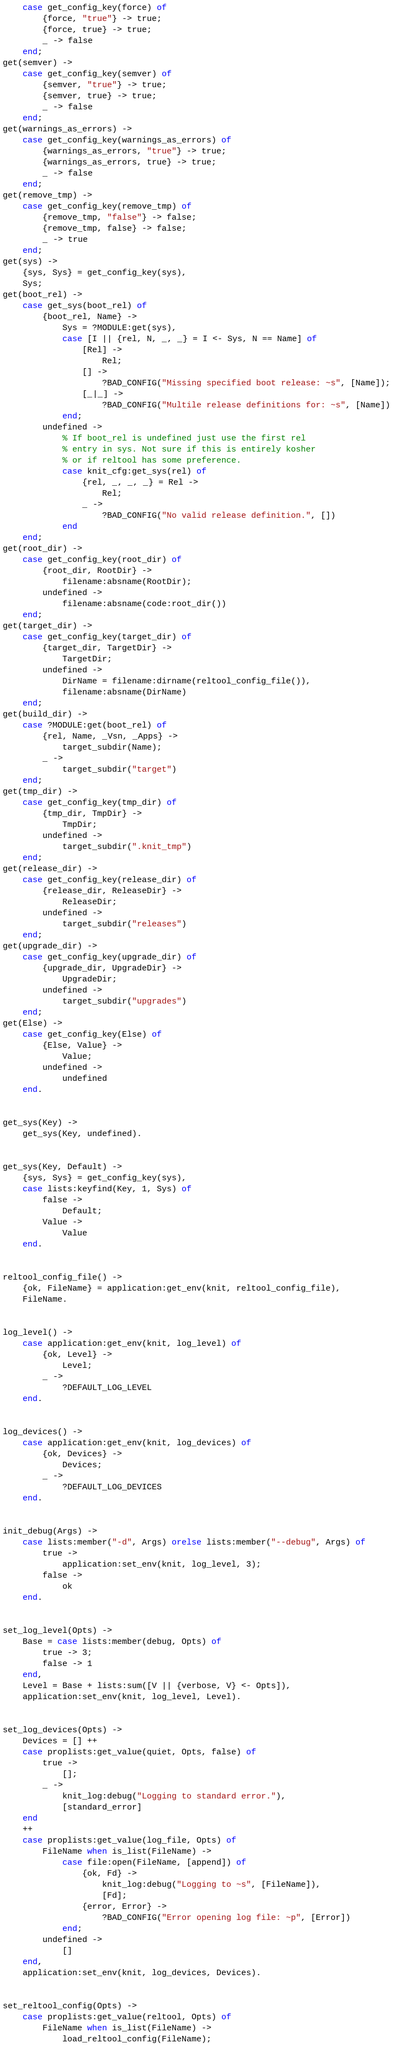<code> <loc_0><loc_0><loc_500><loc_500><_Erlang_>    case get_config_key(force) of
        {force, "true"} -> true;
        {force, true} -> true;
        _ -> false
    end;
get(semver) ->
    case get_config_key(semver) of
        {semver, "true"} -> true;
        {semver, true} -> true;
        _ -> false
    end;
get(warnings_as_errors) ->
    case get_config_key(warnings_as_errors) of
        {warnings_as_errors, "true"} -> true;
        {warnings_as_errors, true} -> true;
        _ -> false
    end;
get(remove_tmp) ->
    case get_config_key(remove_tmp) of
        {remove_tmp, "false"} -> false;
        {remove_tmp, false} -> false;
        _ -> true
    end;
get(sys) ->
    {sys, Sys} = get_config_key(sys),
    Sys;
get(boot_rel) ->
    case get_sys(boot_rel) of
        {boot_rel, Name} ->
            Sys = ?MODULE:get(sys),
            case [I || {rel, N, _, _} = I <- Sys, N == Name] of
                [Rel] ->
                    Rel;
                [] ->
                    ?BAD_CONFIG("Missing specified boot release: ~s", [Name]);
                [_|_] ->
                    ?BAD_CONFIG("Multile release definitions for: ~s", [Name])
            end;
        undefined ->
            % If boot_rel is undefined just use the first rel
            % entry in sys. Not sure if this is entirely kosher
            % or if reltool has some preference.
            case knit_cfg:get_sys(rel) of
                {rel, _, _, _} = Rel ->
                    Rel;
                _ ->
                    ?BAD_CONFIG("No valid release definition.", [])
            end
    end;
get(root_dir) ->
    case get_config_key(root_dir) of
        {root_dir, RootDir} ->
            filename:absname(RootDir);
        undefined ->
            filename:absname(code:root_dir())
    end;
get(target_dir) ->
    case get_config_key(target_dir) of
        {target_dir, TargetDir} ->
            TargetDir;
        undefined ->
            DirName = filename:dirname(reltool_config_file()),
            filename:absname(DirName)
    end;
get(build_dir) ->
    case ?MODULE:get(boot_rel) of
        {rel, Name, _Vsn, _Apps} ->
            target_subdir(Name);
        _ ->
            target_subdir("target")
    end;
get(tmp_dir) ->
    case get_config_key(tmp_dir) of
        {tmp_dir, TmpDir} ->
            TmpDir;
        undefined ->
            target_subdir(".knit_tmp")
    end;
get(release_dir) ->
    case get_config_key(release_dir) of
        {release_dir, ReleaseDir} ->
            ReleaseDir;
        undefined ->
            target_subdir("releases")
    end;
get(upgrade_dir) ->
    case get_config_key(upgrade_dir) of
        {upgrade_dir, UpgradeDir} ->
            UpgradeDir;
        undefined ->
            target_subdir("upgrades")
    end;
get(Else) ->
    case get_config_key(Else) of
        {Else, Value} ->
            Value;
        undefined ->
            undefined
    end.


get_sys(Key) ->
    get_sys(Key, undefined).


get_sys(Key, Default) ->
    {sys, Sys} = get_config_key(sys),
    case lists:keyfind(Key, 1, Sys) of
        false ->
            Default;
        Value ->
            Value
    end.


reltool_config_file() ->
    {ok, FileName} = application:get_env(knit, reltool_config_file),
    FileName.


log_level() ->
    case application:get_env(knit, log_level) of
        {ok, Level} ->
            Level;
        _ ->
            ?DEFAULT_LOG_LEVEL
    end.


log_devices() ->
    case application:get_env(knit, log_devices) of
        {ok, Devices} ->
            Devices;
        _ ->
            ?DEFAULT_LOG_DEVICES
    end.


init_debug(Args) ->
    case lists:member("-d", Args) orelse lists:member("--debug", Args) of
        true ->
            application:set_env(knit, log_level, 3);
        false ->
            ok
    end.


set_log_level(Opts) ->
    Base = case lists:member(debug, Opts) of
        true -> 3;
        false -> 1
    end,
    Level = Base + lists:sum([V || {verbose, V} <- Opts]),
    application:set_env(knit, log_level, Level).


set_log_devices(Opts) ->
    Devices = [] ++
    case proplists:get_value(quiet, Opts, false) of
        true ->
            [];
        _ ->
            knit_log:debug("Logging to standard error."),
            [standard_error]
    end
    ++
    case proplists:get_value(log_file, Opts) of
        FileName when is_list(FileName) ->
            case file:open(FileName, [append]) of
                {ok, Fd} ->
                    knit_log:debug("Logging to ~s", [FileName]),
                    [Fd];
                {error, Error} ->
                    ?BAD_CONFIG("Error opening log file: ~p", [Error])
            end;
        undefined ->
            []
    end,
    application:set_env(knit, log_devices, Devices).


set_reltool_config(Opts) ->
    case proplists:get_value(reltool, Opts) of
        FileName when is_list(FileName) ->
            load_reltool_config(FileName);</code> 